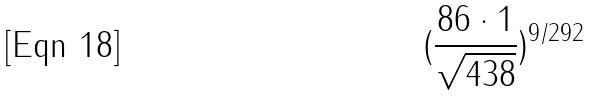Convert formula to latex. <formula><loc_0><loc_0><loc_500><loc_500>( \frac { 8 6 \cdot 1 } { \sqrt { 4 3 8 } } ) ^ { 9 / 2 9 2 }</formula> 